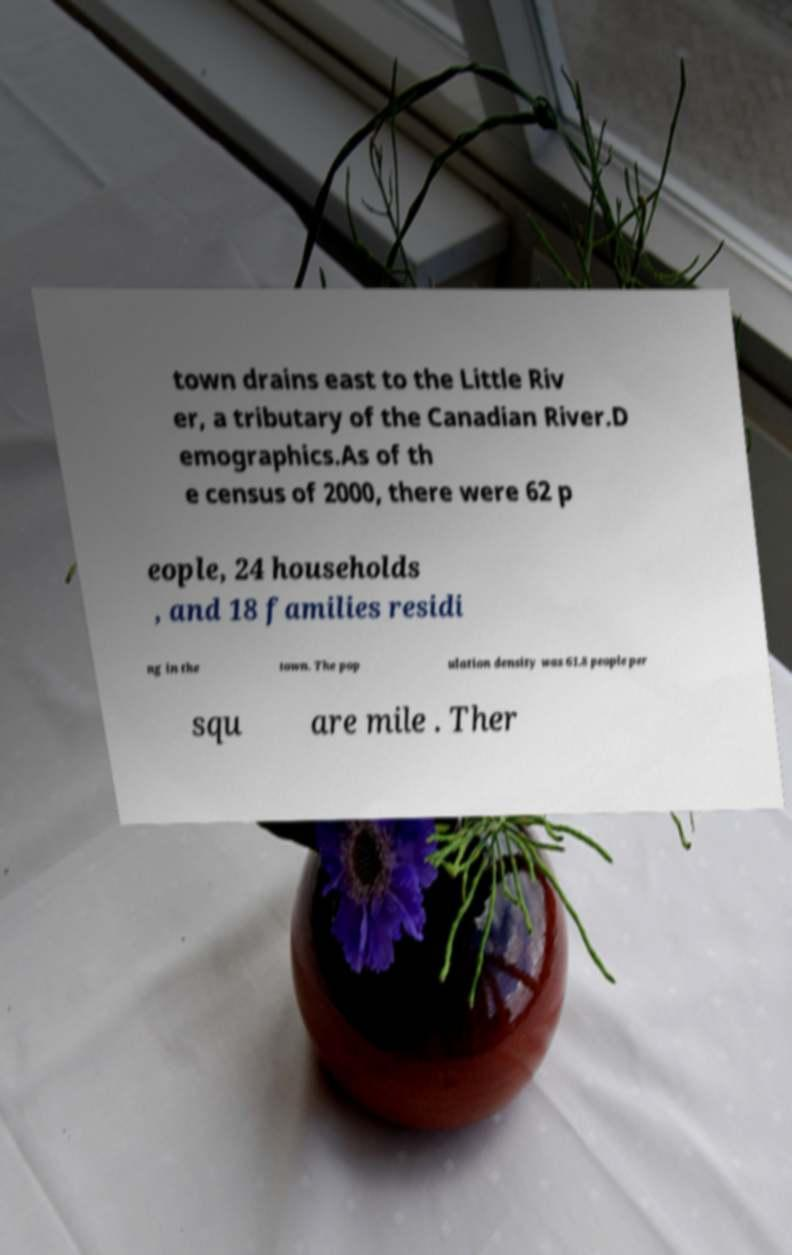What messages or text are displayed in this image? I need them in a readable, typed format. town drains east to the Little Riv er, a tributary of the Canadian River.D emographics.As of th e census of 2000, there were 62 p eople, 24 households , and 18 families residi ng in the town. The pop ulation density was 61.8 people per squ are mile . Ther 